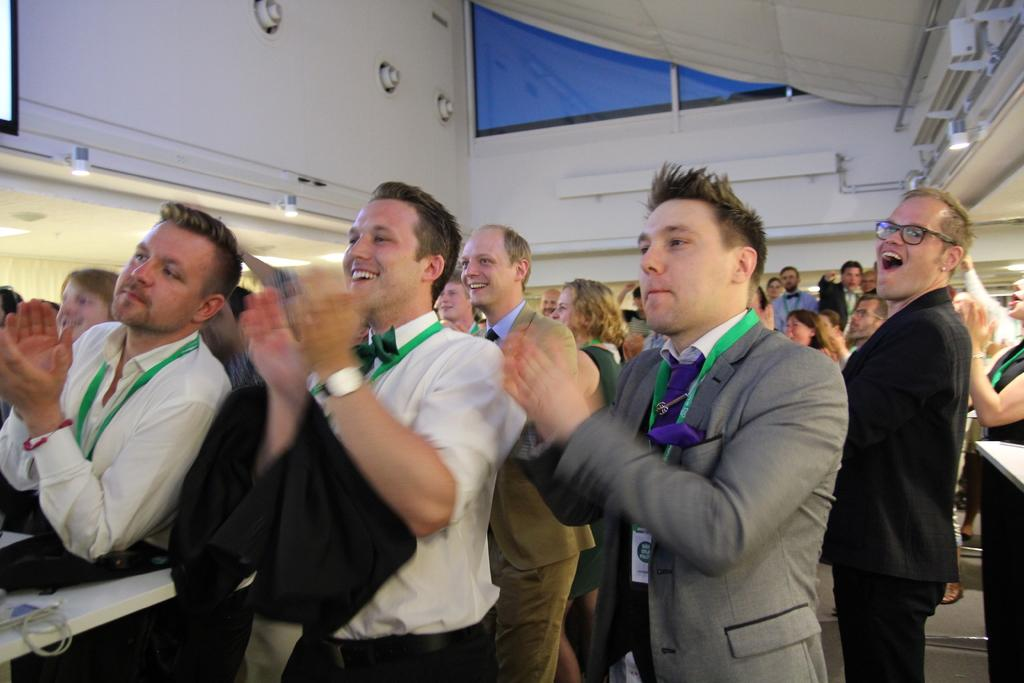Who or what is in the image? There are people in the image. What are some of the people doing? Some of the people are clapping. What else can be seen in the image besides people? There are objects on a table, walls, a rooftop, and lights visible in the image. What type of force is being exerted by the people in the image? There is no specific force being exerted by the people in the image; they are simply clapping. What songs are being sung by the people in the image? There is no information about songs being sung in the image; we only know that some people are clapping. 